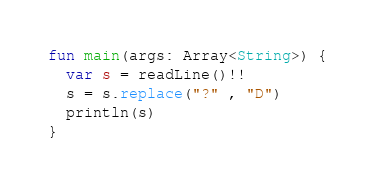Convert code to text. <code><loc_0><loc_0><loc_500><loc_500><_Kotlin_>fun main(args: Array<String>) {
  var s = readLine()!!
  s = s.replace("?" , "D")
  println(s)
}
</code> 